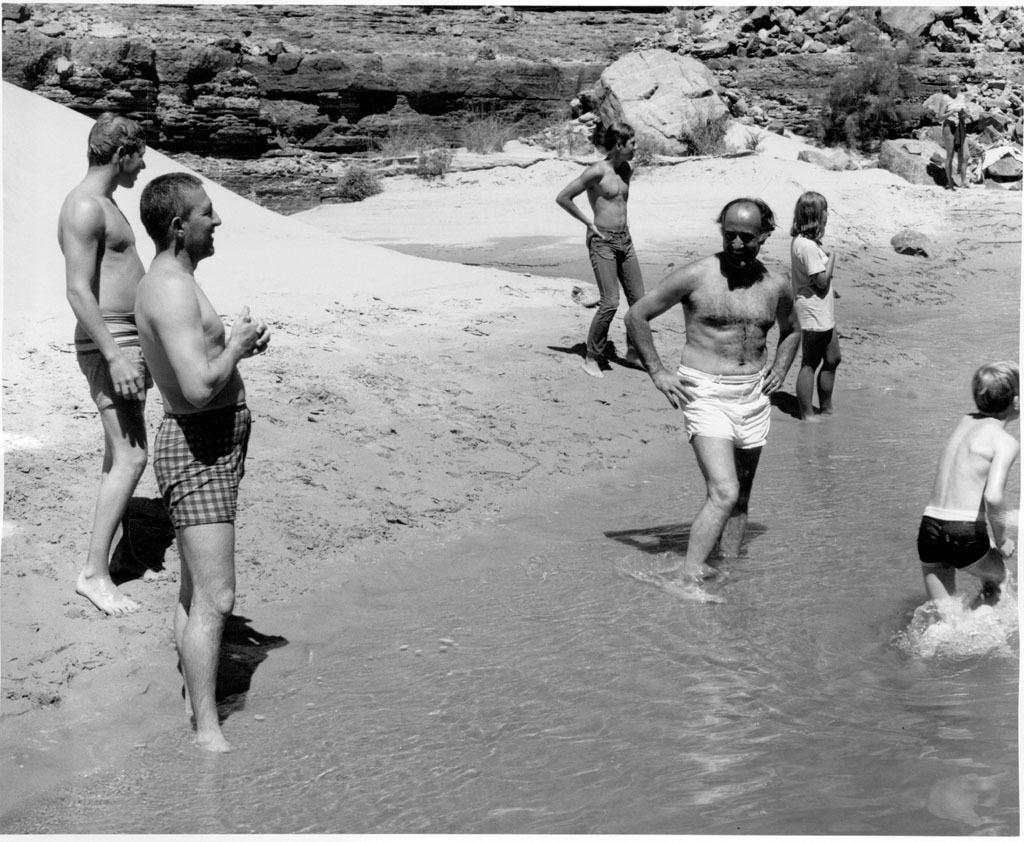What type of surface can be seen beneath the people in the image? The people are standing on the sand in the image. Are there any people in the water in the image? Yes, there are people standing in the water in the image. What type of structures can be seen in the background of the image? There are rock walls visible in the image. What type of activity is the tramp participating in with the team in the image? There is no tramp or team present in the image; it features people standing on sand and in the water. 